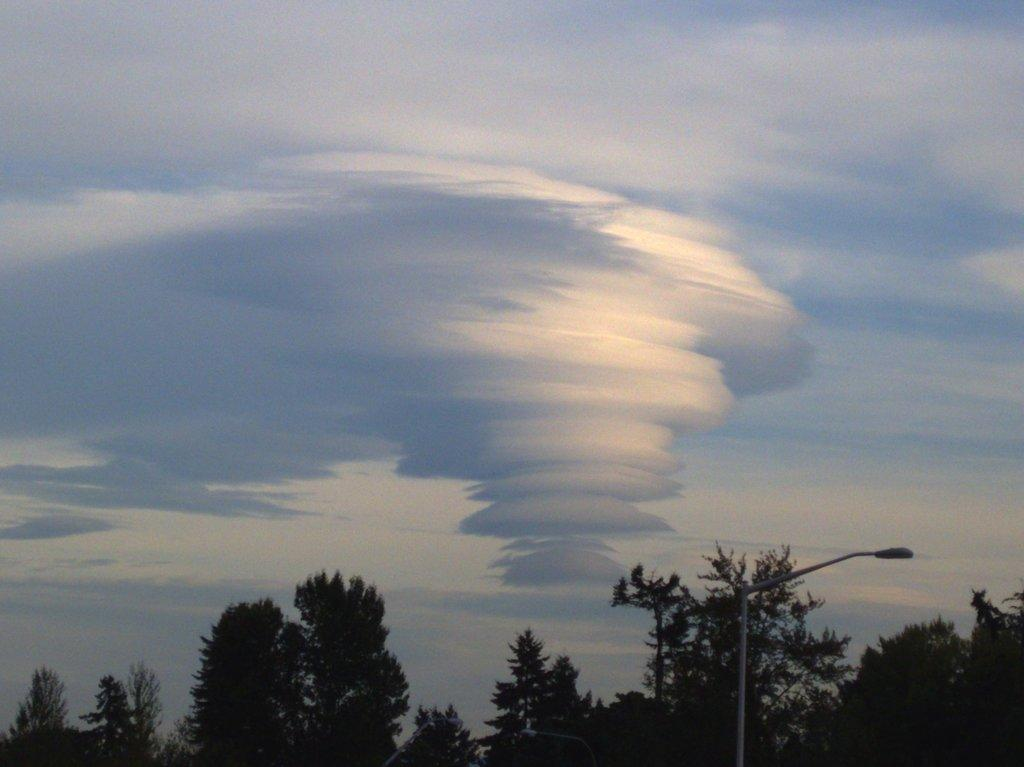What type of vegetation can be seen in the image? There are trees in the image. What structures are present in the image? There are light poles in the image. What can be seen in the sky in the image? Clouds are visible in the sky in the image. How many fowl are perched on the light poles in the image? There are no fowl present in the image; it only features trees, light poles, and clouds. What type of tool is being used to tighten the bolts on the trees in the image? There is no tool or any indication of maintenance work being done on the trees in the image. 